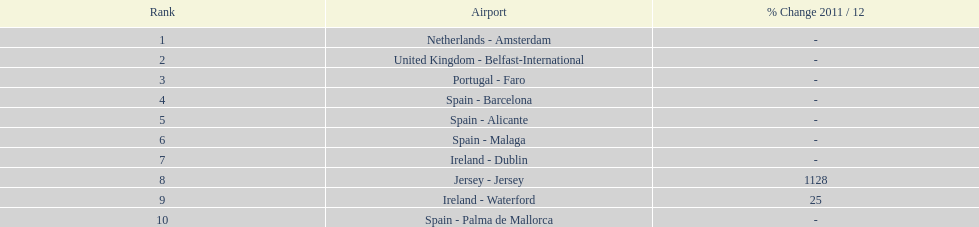Could you help me parse every detail presented in this table? {'header': ['Rank', 'Airport', '% Change 2011 / 12'], 'rows': [['1', 'Netherlands - Amsterdam', '-'], ['2', 'United Kingdom - Belfast-International', '-'], ['3', 'Portugal - Faro', '-'], ['4', 'Spain - Barcelona', '-'], ['5', 'Spain - Alicante', '-'], ['6', 'Spain - Malaga', '-'], ['7', 'Ireland - Dublin', '-'], ['8', 'Jersey - Jersey', '1128'], ['9', 'Ireland - Waterford', '25'], ['10', 'Spain - Palma de Mallorca', '-']]} Where is the most popular destination for passengers leaving london southend airport? Netherlands - Amsterdam. 